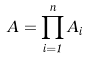<formula> <loc_0><loc_0><loc_500><loc_500>A = \prod _ { i = 1 } ^ { n } A _ { i }</formula> 